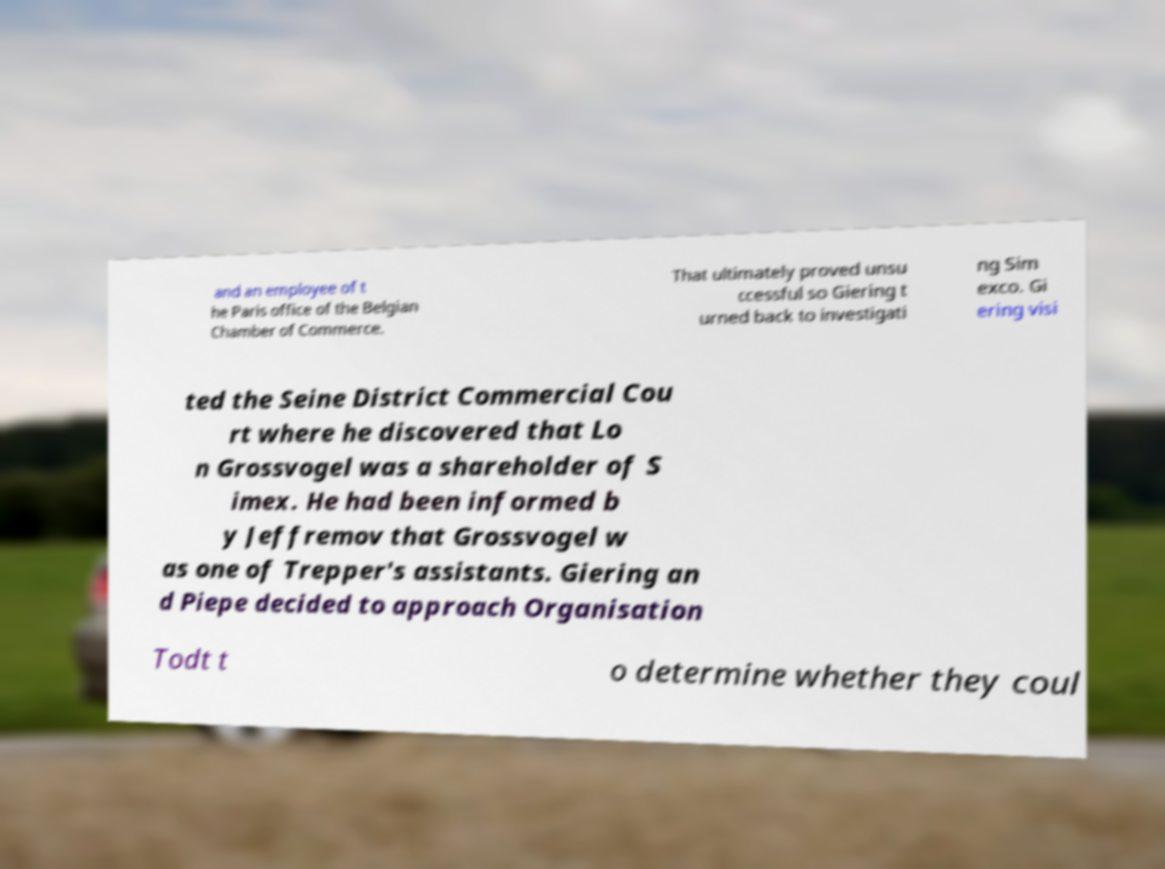Could you extract and type out the text from this image? and an employee of t he Paris office of the Belgian Chamber of Commerce. That ultimately proved unsu ccessful so Giering t urned back to investigati ng Sim exco. Gi ering visi ted the Seine District Commercial Cou rt where he discovered that Lo n Grossvogel was a shareholder of S imex. He had been informed b y Jeffremov that Grossvogel w as one of Trepper's assistants. Giering an d Piepe decided to approach Organisation Todt t o determine whether they coul 